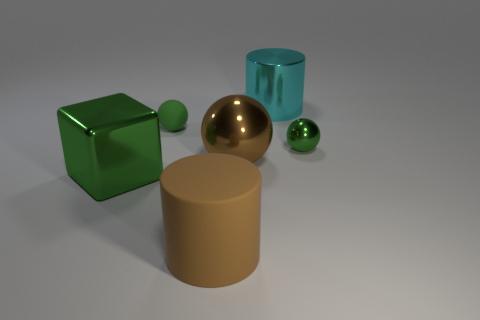Subtract all tiny metallic spheres. How many spheres are left? 2 Subtract all brown balls. How many balls are left? 2 Subtract all cylinders. How many objects are left? 4 Subtract 1 cubes. How many cubes are left? 0 Add 3 large objects. How many objects exist? 9 Subtract all purple blocks. Subtract all blue cylinders. How many blocks are left? 1 Subtract all cyan spheres. How many brown cylinders are left? 1 Subtract all shiny blocks. Subtract all blocks. How many objects are left? 4 Add 6 tiny metallic objects. How many tiny metallic objects are left? 7 Add 1 big rubber objects. How many big rubber objects exist? 2 